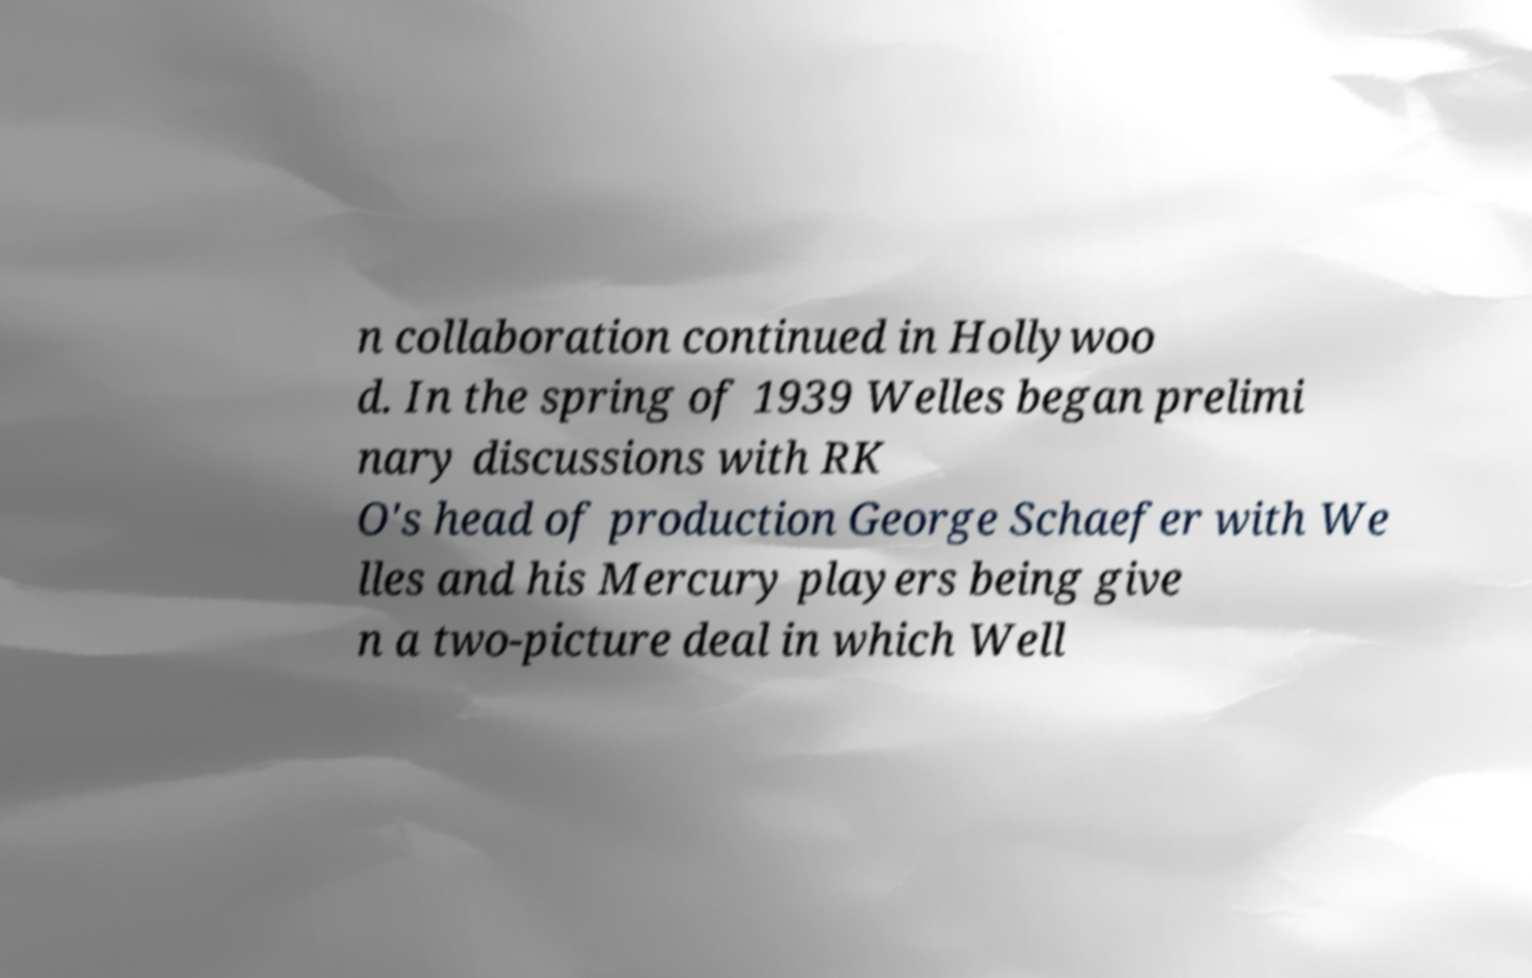What messages or text are displayed in this image? I need them in a readable, typed format. n collaboration continued in Hollywoo d. In the spring of 1939 Welles began prelimi nary discussions with RK O's head of production George Schaefer with We lles and his Mercury players being give n a two-picture deal in which Well 